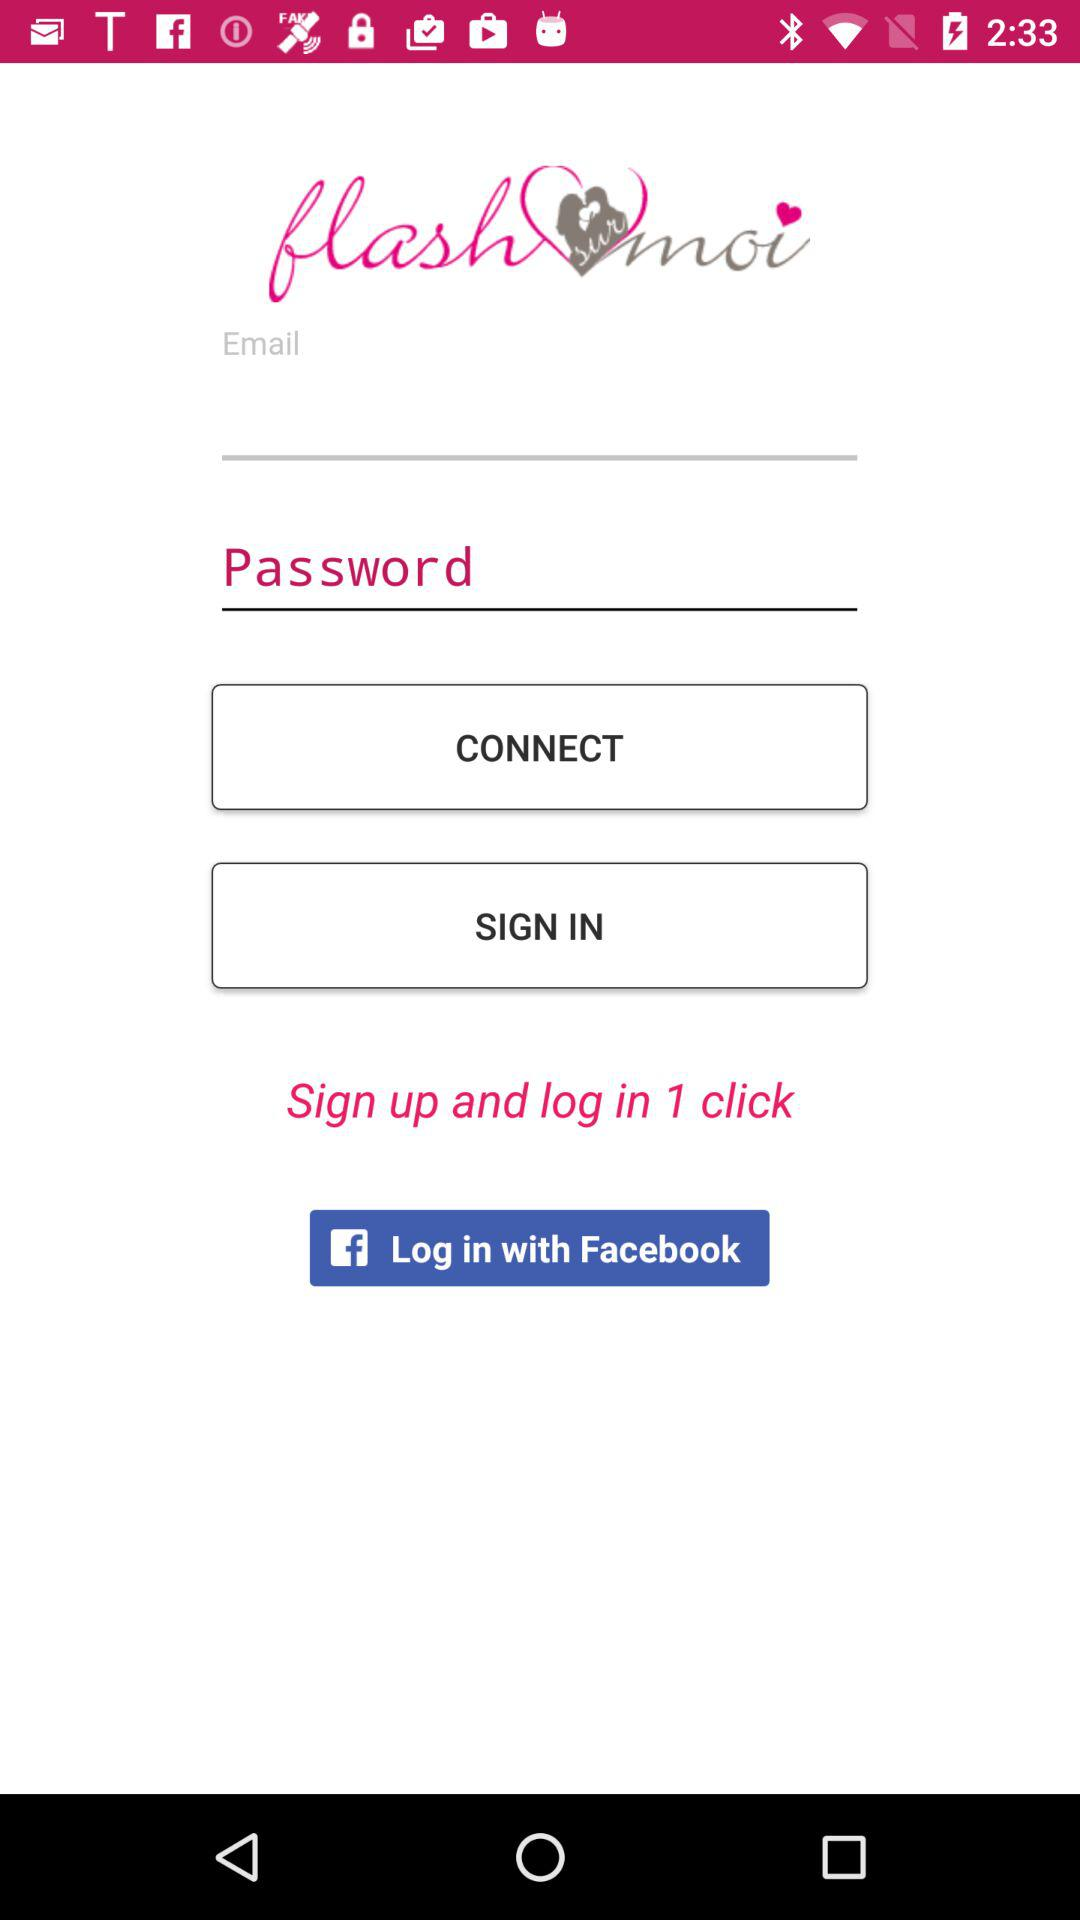What is the name of the application asking for an email and password? The name of the application is "flash sur moi". 